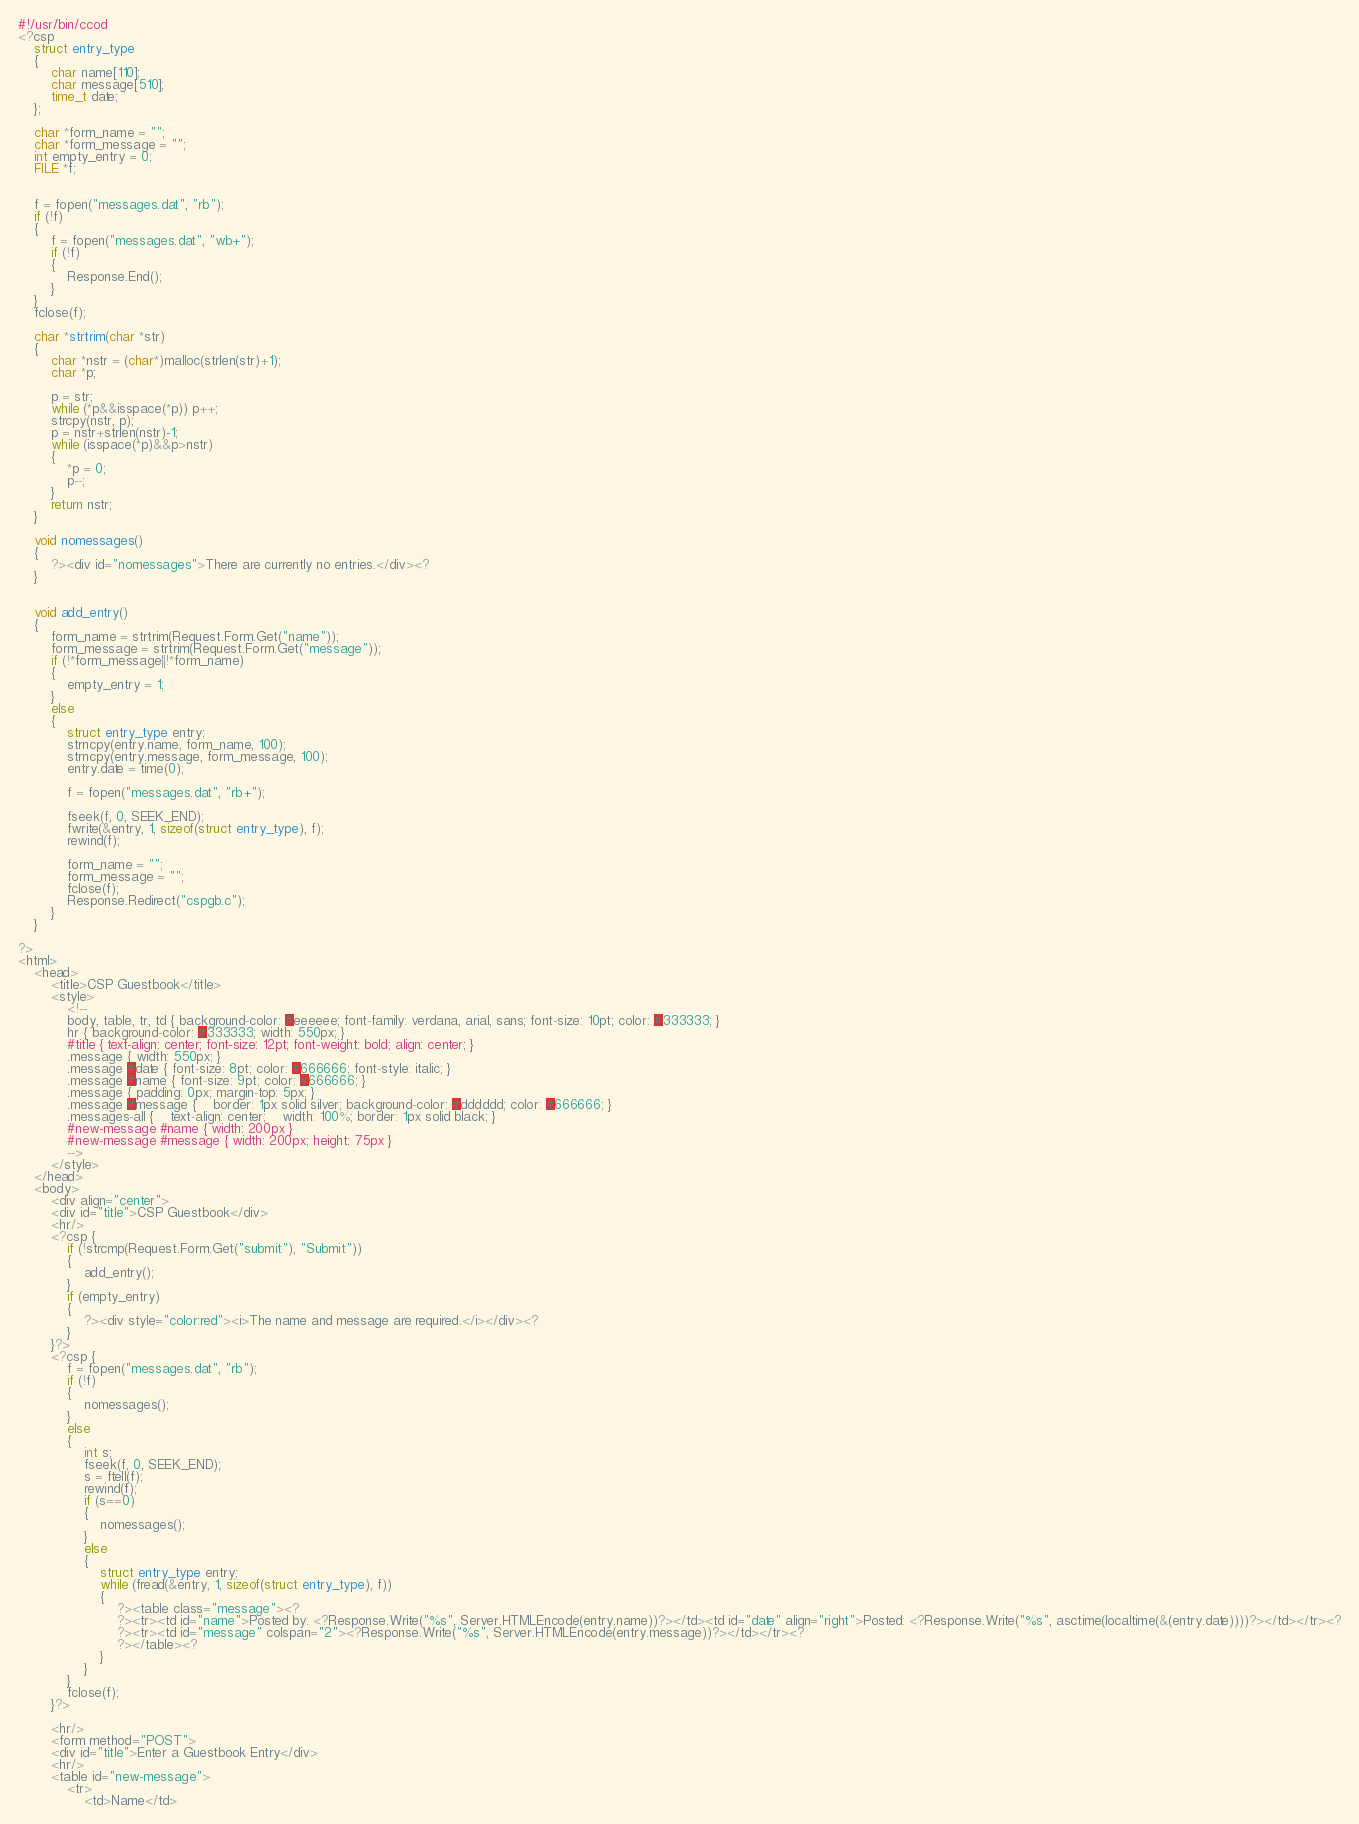Convert code to text. <code><loc_0><loc_0><loc_500><loc_500><_C_>#!/usr/bin/ccod
<?csp
	struct entry_type
	{
    	char name[110];
		char message[510];
		time_t date;
	};

	char *form_name = "";
	char *form_message = "";
	int empty_entry = 0;
	FILE *f;


	f = fopen("messages.dat", "rb");
	if (!f)
	{
		f = fopen("messages.dat", "wb+");
		if (!f)
		{
			Response.End();
		}
	}
	fclose(f);
	
	char *strtrim(char *str)
	{
		char *nstr = (char*)malloc(strlen(str)+1);
		char *p;
	
		p = str;
		while (*p&&isspace(*p)) p++;
		strcpy(nstr, p);
		p = nstr+strlen(nstr)-1;
		while (isspace(*p)&&p>nstr)
		{
			*p = 0;
			p--;
		}
		return nstr;
	} 
	
	void nomessages()
	{
		?><div id="nomessages">There are currently no entries.</div><?
	}

	
	void add_entry()
	{
		form_name = strtrim(Request.Form.Get("name"));
		form_message = strtrim(Request.Form.Get("message"));
		if (!*form_message||!*form_name)
		{
			empty_entry = 1;
		}
		else
		{
			struct entry_type entry;
			strncpy(entry.name, form_name, 100);
			strncpy(entry.message, form_message, 100);
			entry.date = time(0);

   			f = fopen("messages.dat", "rb+");
			
			fseek(f, 0, SEEK_END);
			fwrite(&entry, 1, sizeof(struct entry_type), f);
			rewind(f);
			
			form_name = "";
			form_message = "";
			fclose(f);
			Response.Redirect("cspgb.c");
		}
	}

?>
<html>
	<head>
		<title>CSP Guestbook</title>
		<style>
			<!--
			body, table, tr, td { background-color: #eeeeee; font-family: verdana, arial, sans; font-size: 10pt; color: #333333; }
			hr { background-color: #333333; width: 550px; }
			#title { text-align: center; font-size: 12pt; font-weight: bold; align: center; }
			.message { width: 550px; }
			.message #date { font-size: 8pt; color: #666666; font-style: italic; }
			.message #name { font-size: 9pt; color: #666666; }
			.message { padding: 0px; margin-top: 5px; }
			.message #message {	border: 1px solid silver; background-color: #dddddd; color: #666666; }
			.messages-all {	text-align: center;	width: 100%; border: 1px solid black; }
			#new-message #name { width: 200px }
			#new-message #message { width: 200px; height: 75px }
			-->
		</style>
	</head>
	<body>
		<div align="center">
		<div id="title">CSP Guestbook</div>
		<hr/>
		<?csp {
			if (!strcmp(Request.Form.Get("submit"), "Submit"))
			{
				add_entry();
			}
			if (empty_entry)
			{
				?><div style="color:red"><i>The name and message are required.</i></div><?
			}
		}?>
		<?csp {
			f = fopen("messages.dat", "rb");
			if (!f)
			{
		    	nomessages(); 	
			}
			else
			{
				int s;
				fseek(f, 0, SEEK_END);
				s = ftell(f);
				rewind(f);
				if (s==0)
				{
					nomessages();
				}
				else
				{
					struct entry_type entry;
				  	while (fread(&entry, 1, sizeof(struct entry_type), f))
					{
						?><table class="message"><?
						?><tr><td id="name">Posted by: <?Response.Write("%s", Server.HTMLEncode(entry.name))?></td><td id="date" align="right">Posted: <?Response.Write("%s", asctime(localtime(&(entry.date))))?></td></tr><?
						?><tr><td id="message" colspan="2"><?Response.Write("%s", Server.HTMLEncode(entry.message))?></td></tr><?							
						?></table><?
					}
				}
			}
			fclose(f);
		}?>

		<hr/>
		<form method="POST">
		<div id="title">Enter a Guestbook Entry</div>
		<hr/>
		<table id="new-message">
			<tr>
				<td>Name</td></code> 